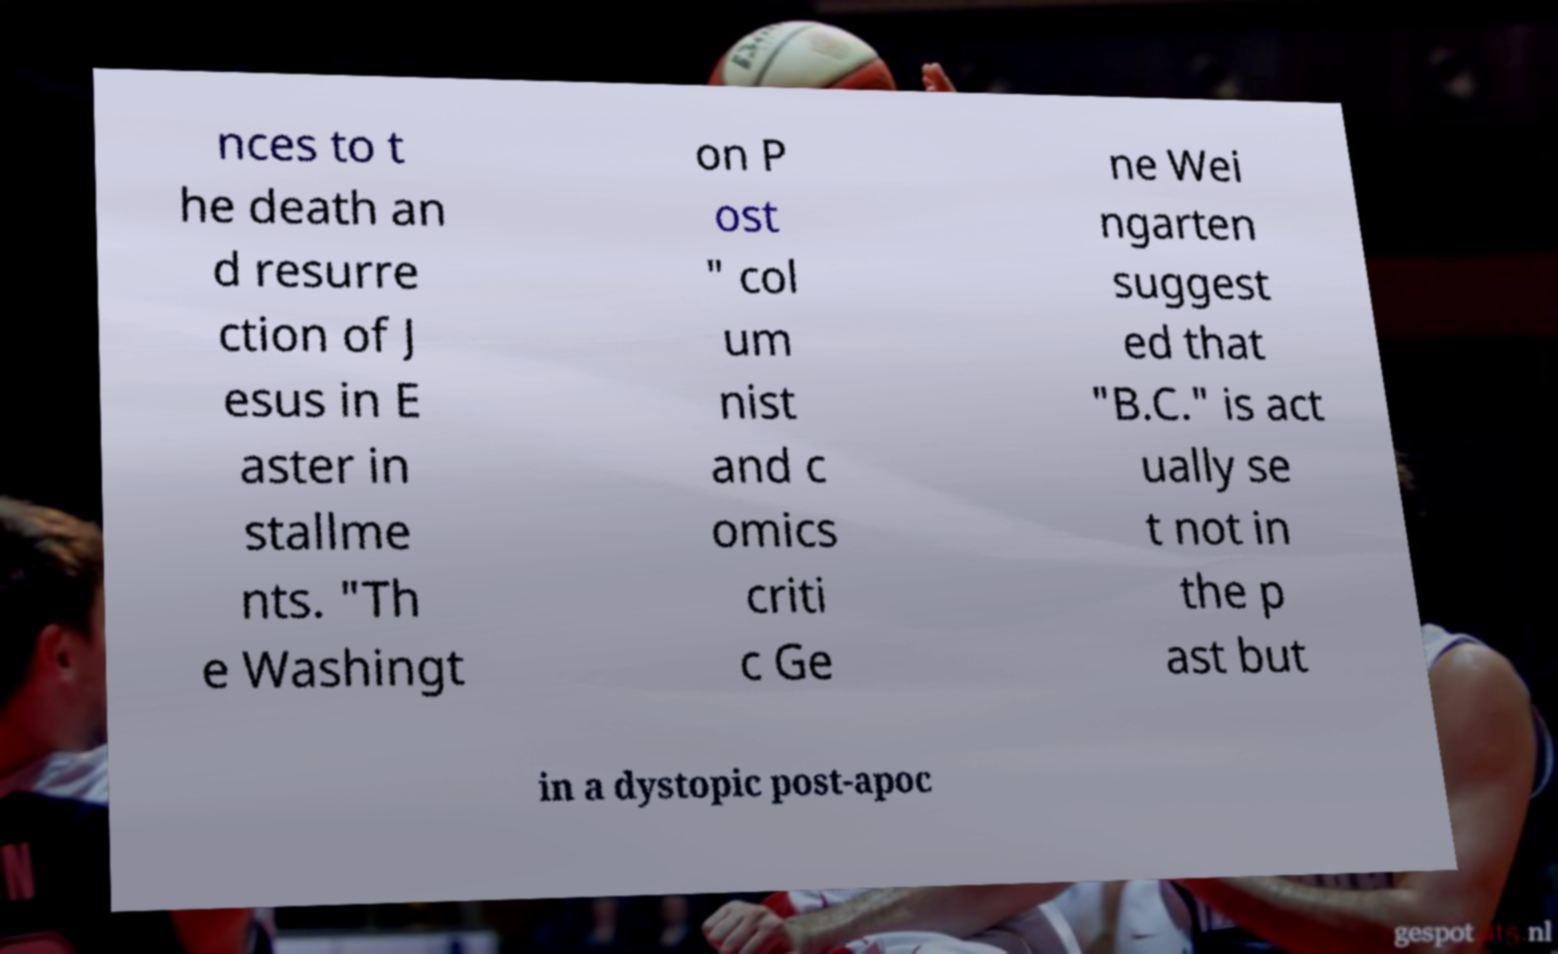Please identify and transcribe the text found in this image. nces to t he death an d resurre ction of J esus in E aster in stallme nts. "Th e Washingt on P ost " col um nist and c omics criti c Ge ne Wei ngarten suggest ed that "B.C." is act ually se t not in the p ast but in a dystopic post-apoc 